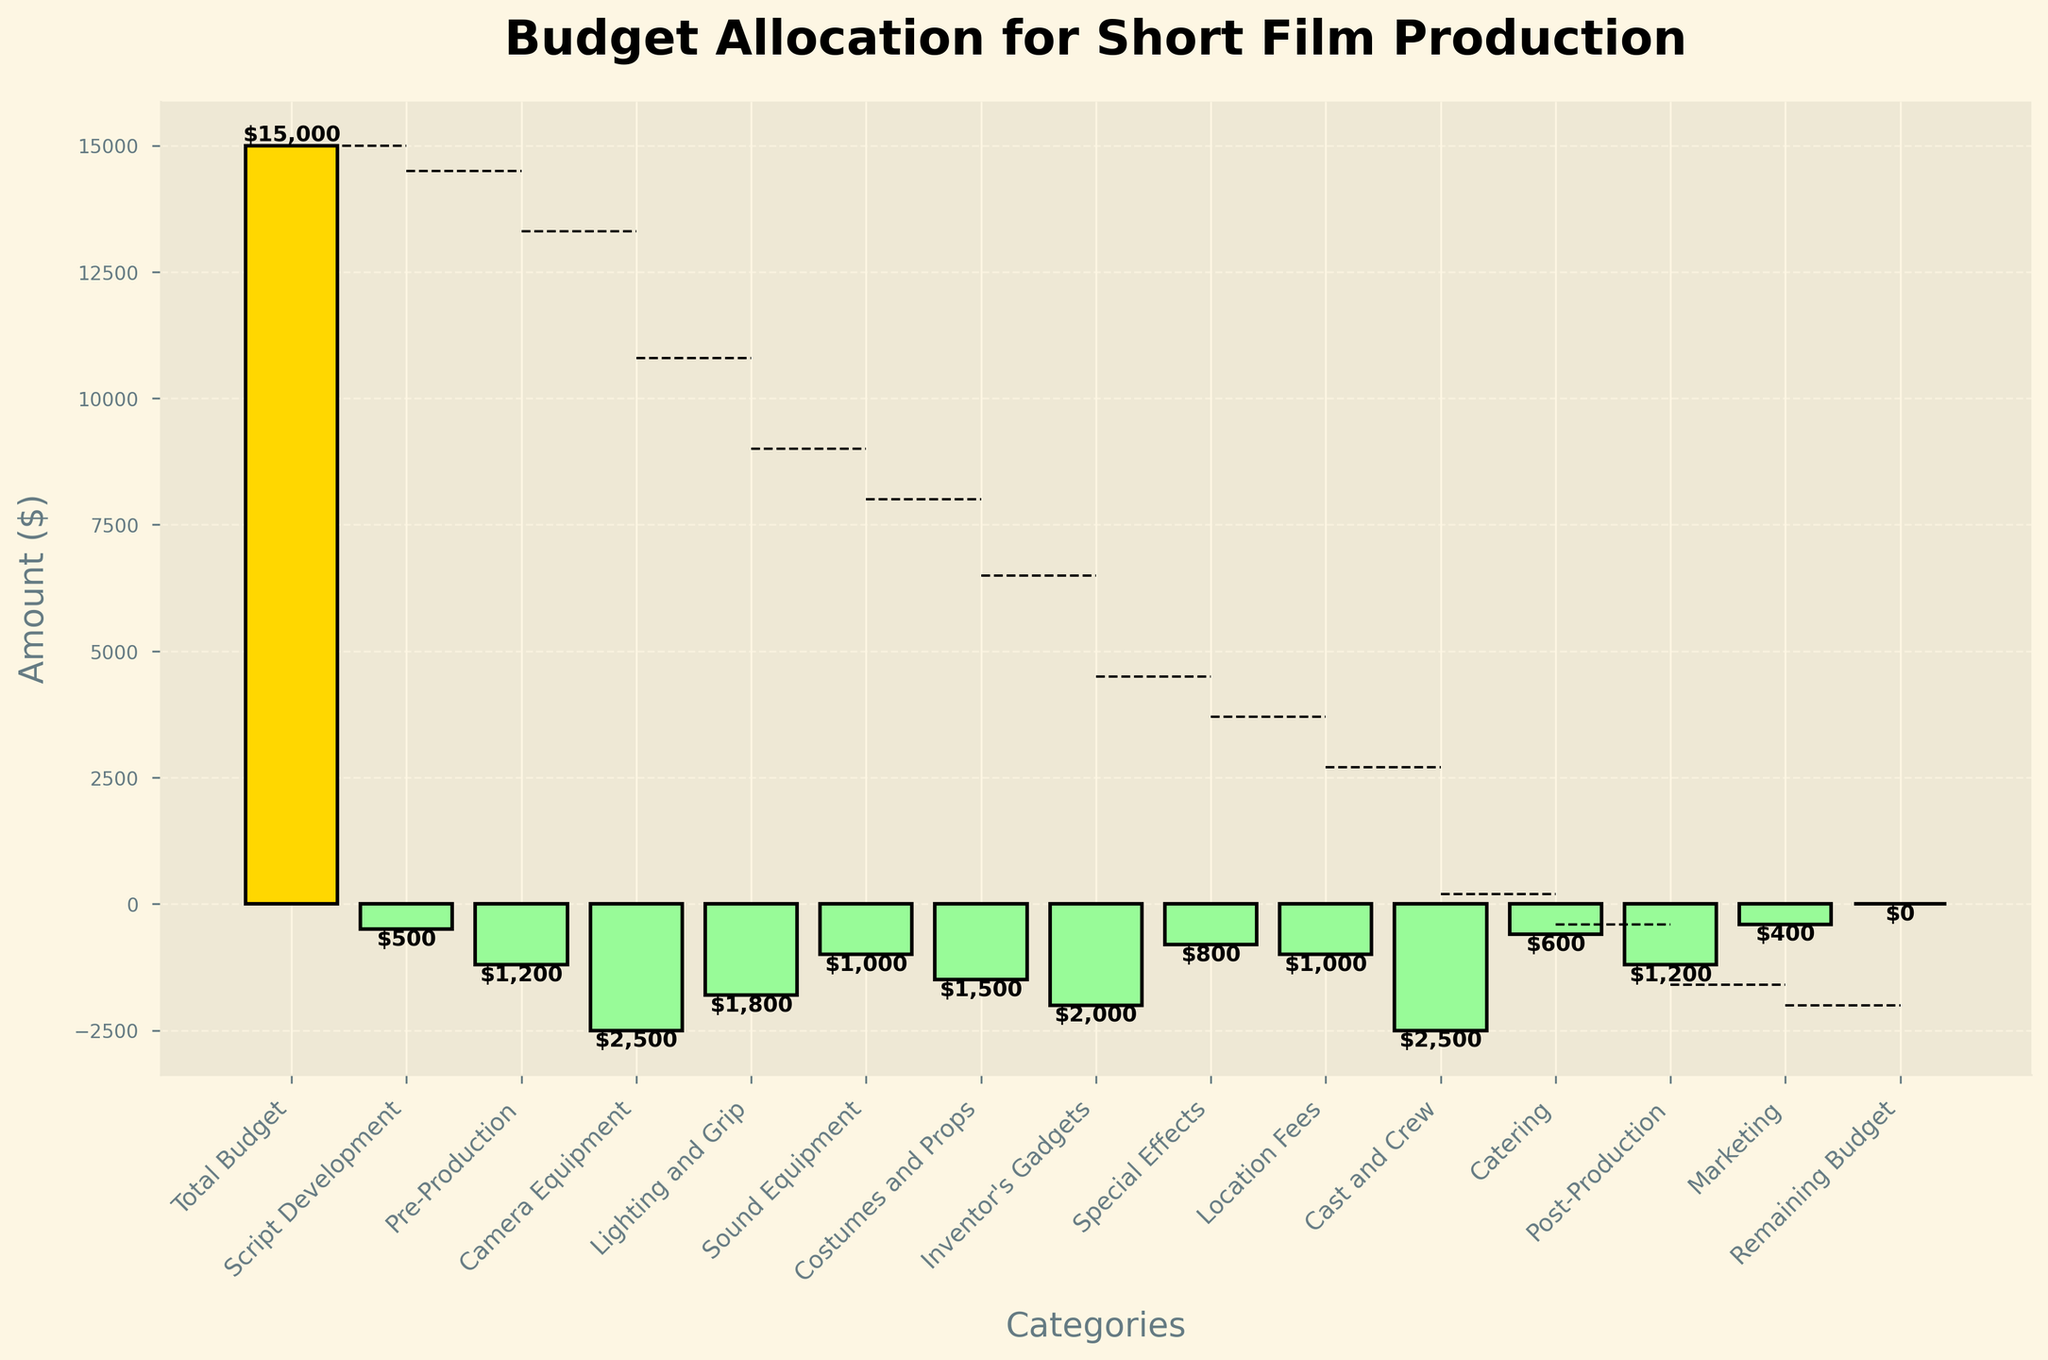What's the title of the chart? The title is positioned at the top of the chart in a large, bold font. It usually states the main subject of the chart.
Answer: Budget Allocation for Short Film Production How much was spent on Camera Equipment? Locate the bar labeled "Camera Equipment" on the x-axis, then read the corresponding value from the bar. The value here is printed near the top of the bar.
Answer: $2,500 What's the total initial budget for the short film? The initial budget is represented by the first bar on the left, which typically has a distinctive color. The value is written next to this bar.
Answer: $15,000 What is the remaining budget after all the expenses? The remaining budget is shown by the last bar on the chart, typically in a different color to differentiate it from other categories. The value is written next to this bar.
Answer: $0 Which category had the highest expense? Compare the lengths of all the bars representing expenses (those with negative values) and identify the longest one. The value helps confirm the comparison.
Answer: Camera Equipment Which expense is higher, Costumes and Props or Inventor's Gadgets? Compare the lengths of the bars labeled "Costumes and Props" and "Inventor's Gadgets". The bar that is longer represents a higher expense.
Answer: Inventor's Gadgets Which expense comes immediately before Location Fees? Look at the bar immediately preceding the one labeled "Location Fees" on the x-axis.
Answer: Special Effects How many categories are listed on the x-axis? Count the number of bars represented on the x-axis. Each bar corresponds to one category.
Answer: 14 